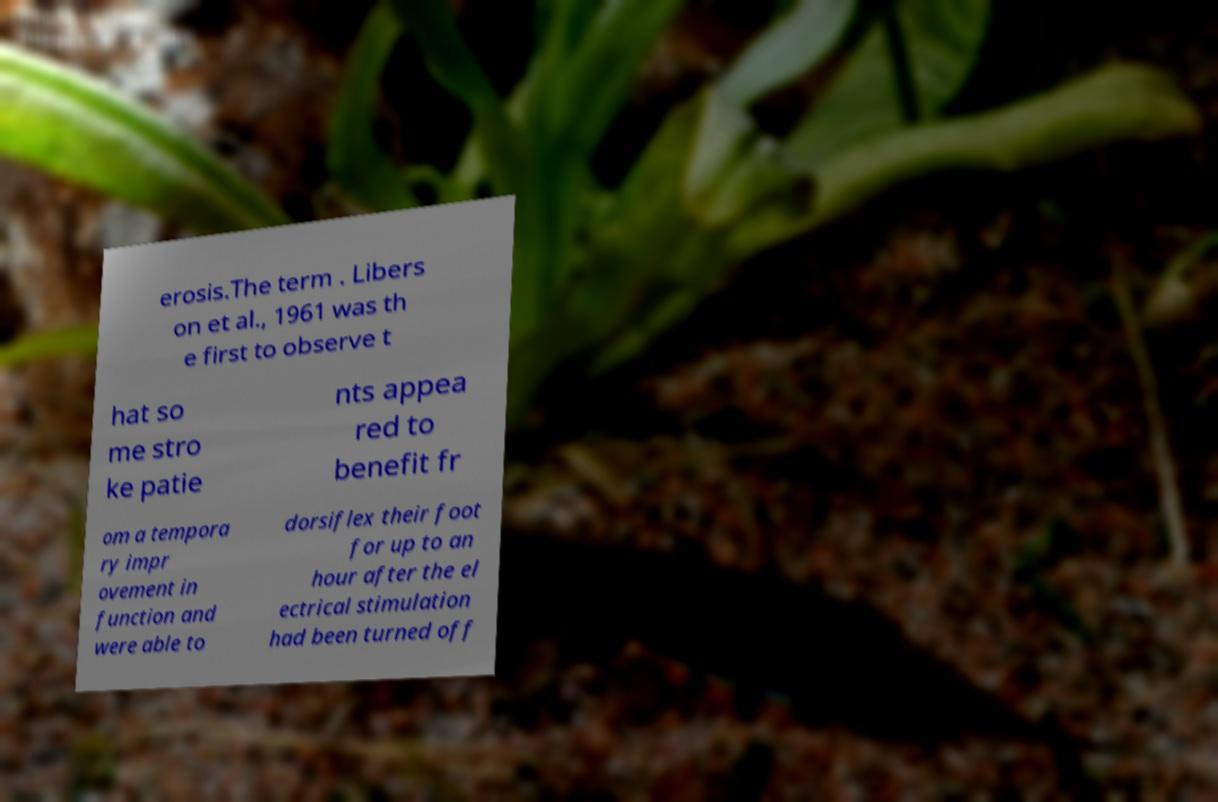For documentation purposes, I need the text within this image transcribed. Could you provide that? erosis.The term . Libers on et al., 1961 was th e first to observe t hat so me stro ke patie nts appea red to benefit fr om a tempora ry impr ovement in function and were able to dorsiflex their foot for up to an hour after the el ectrical stimulation had been turned off 